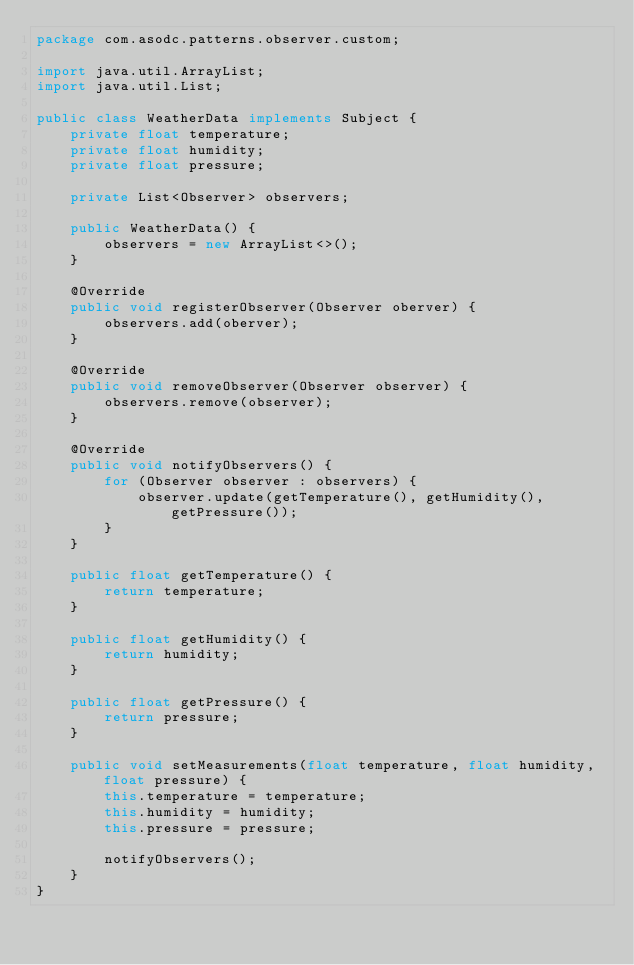<code> <loc_0><loc_0><loc_500><loc_500><_Java_>package com.asodc.patterns.observer.custom;

import java.util.ArrayList;
import java.util.List;

public class WeatherData implements Subject {
    private float temperature;
    private float humidity;
    private float pressure;

    private List<Observer> observers;

    public WeatherData() {
        observers = new ArrayList<>();
    }

    @Override
    public void registerObserver(Observer oberver) {
        observers.add(oberver);
    }

    @Override
    public void removeObserver(Observer observer) {
        observers.remove(observer);
    }

    @Override
    public void notifyObservers() {
        for (Observer observer : observers) {
            observer.update(getTemperature(), getHumidity(), getPressure());
        }
    }

    public float getTemperature() {
        return temperature;
    }

    public float getHumidity() {
        return humidity;
    }

    public float getPressure() {
        return pressure;
    }

    public void setMeasurements(float temperature, float humidity, float pressure) {
        this.temperature = temperature;
        this.humidity = humidity;
        this.pressure = pressure;

        notifyObservers();
    }
}
</code> 